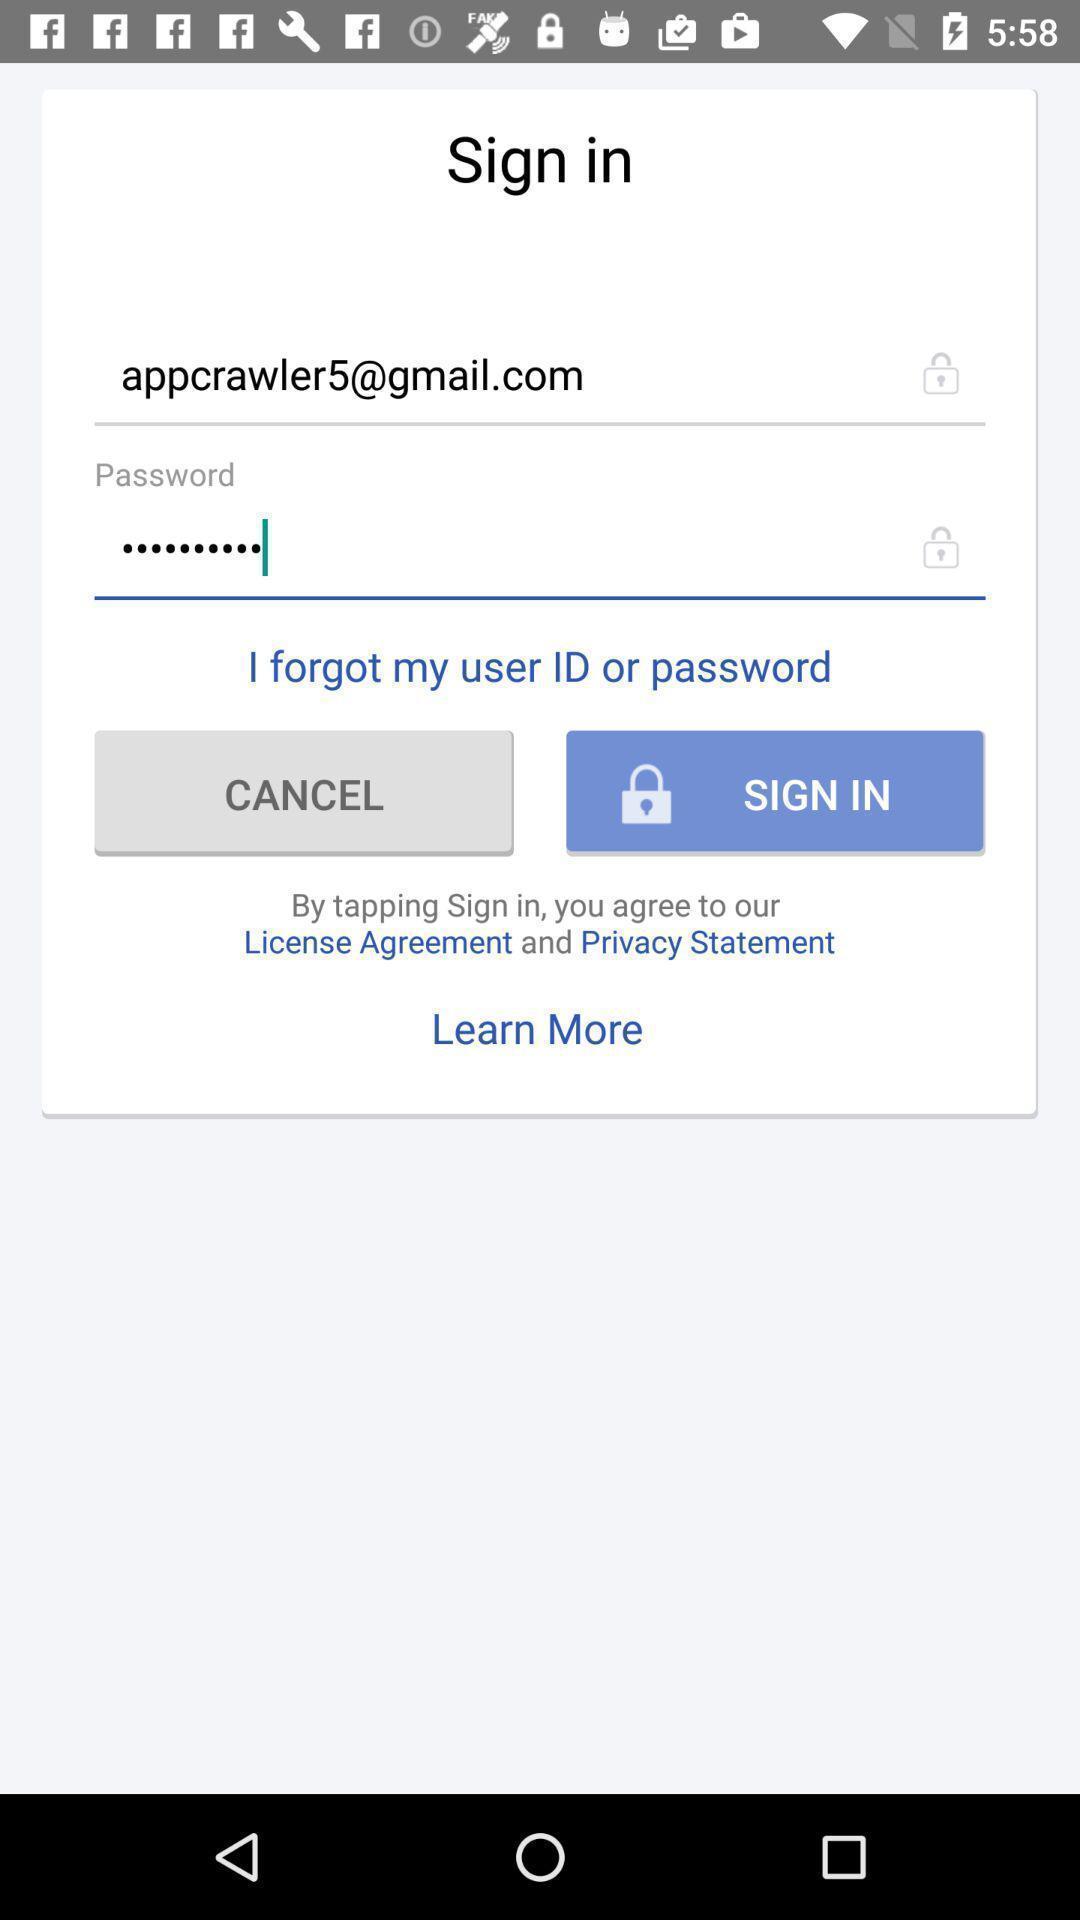Explain what's happening in this screen capture. Sign-in page is showing. 